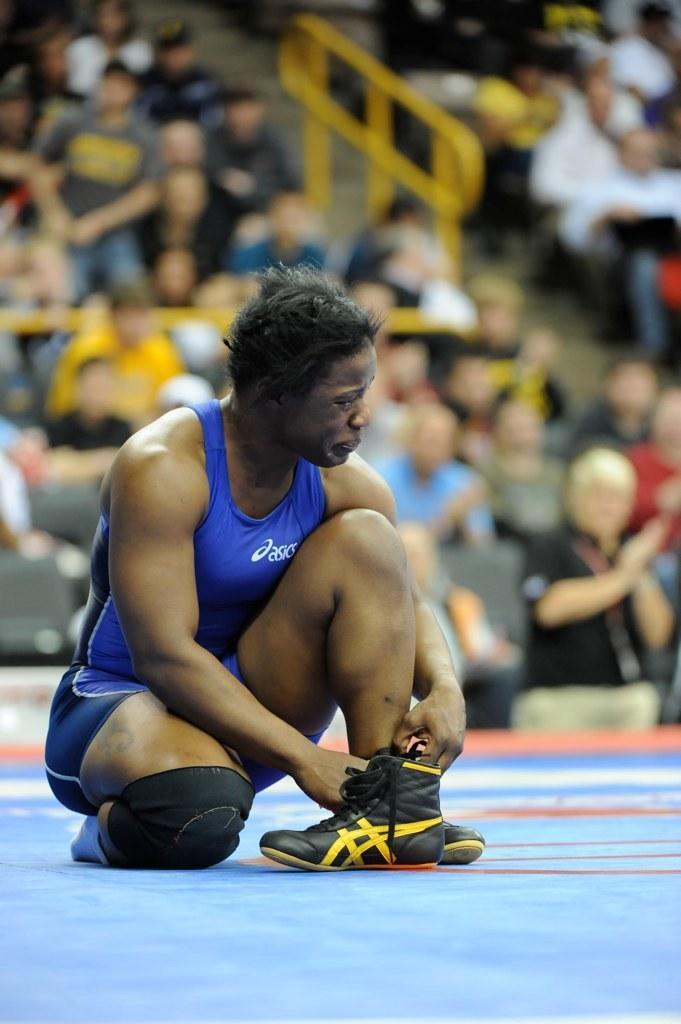How would you summarize this image in a sentence or two? In this picture there is a man in the center of the image and there are other people those who are sitting on the chairs as audience in the background area of the image. 